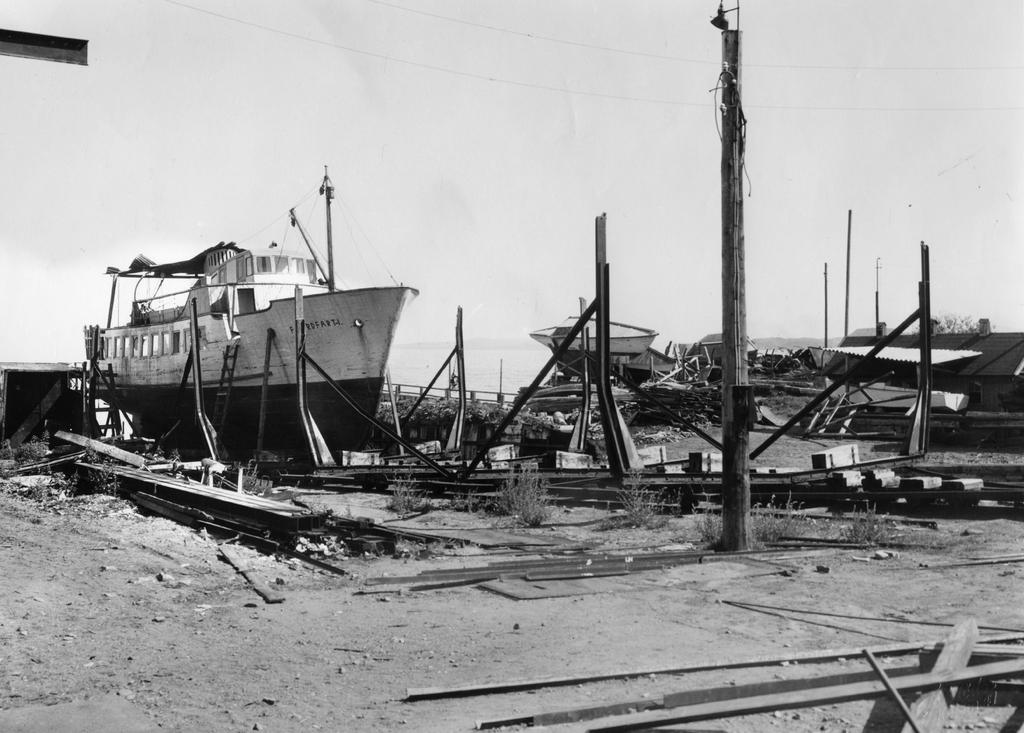What is the color scheme of the image? The image is black and white. What type of vehicles can be seen in the image? There are ships and destroyed boats in the image. What type of structures are present in the image? There are sheds in the image. What type of material is used for the bars in the image? There are wooden bars in the image. What type of natural elements can be seen in the image? There are logs and plants in the image. What part of the natural environment is visible in the image? The sky is visible in the image. What type of roof can be seen on the boats in the image? There are no roofs present on the boats in the image, as they are destroyed. What type of berry is growing on the plants in the image? There is no mention of berries in the image; only plants are mentioned. 